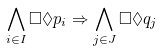Convert formula to latex. <formula><loc_0><loc_0><loc_500><loc_500>\bigwedge _ { i \in I } \Box \Diamond p _ { i } \Rightarrow \bigwedge _ { j \in J } \Box \Diamond q _ { j }</formula> 